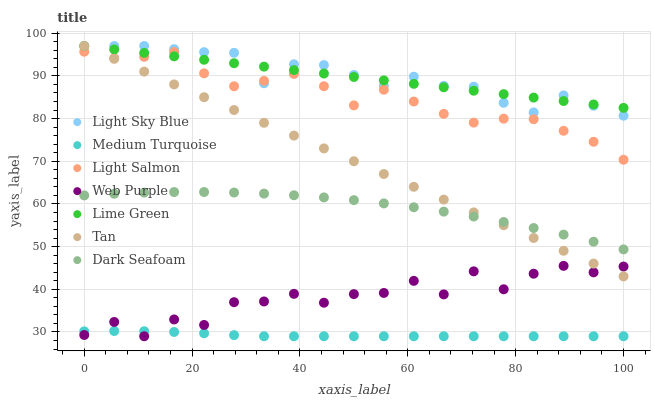Does Medium Turquoise have the minimum area under the curve?
Answer yes or no. Yes. Does Light Sky Blue have the maximum area under the curve?
Answer yes or no. Yes. Does Dark Seafoam have the minimum area under the curve?
Answer yes or no. No. Does Dark Seafoam have the maximum area under the curve?
Answer yes or no. No. Is Tan the smoothest?
Answer yes or no. Yes. Is Web Purple the roughest?
Answer yes or no. Yes. Is Dark Seafoam the smoothest?
Answer yes or no. No. Is Dark Seafoam the roughest?
Answer yes or no. No. Does Web Purple have the lowest value?
Answer yes or no. Yes. Does Dark Seafoam have the lowest value?
Answer yes or no. No. Does Lime Green have the highest value?
Answer yes or no. Yes. Does Dark Seafoam have the highest value?
Answer yes or no. No. Is Medium Turquoise less than Light Sky Blue?
Answer yes or no. Yes. Is Lime Green greater than Medium Turquoise?
Answer yes or no. Yes. Does Tan intersect Dark Seafoam?
Answer yes or no. Yes. Is Tan less than Dark Seafoam?
Answer yes or no. No. Is Tan greater than Dark Seafoam?
Answer yes or no. No. Does Medium Turquoise intersect Light Sky Blue?
Answer yes or no. No. 